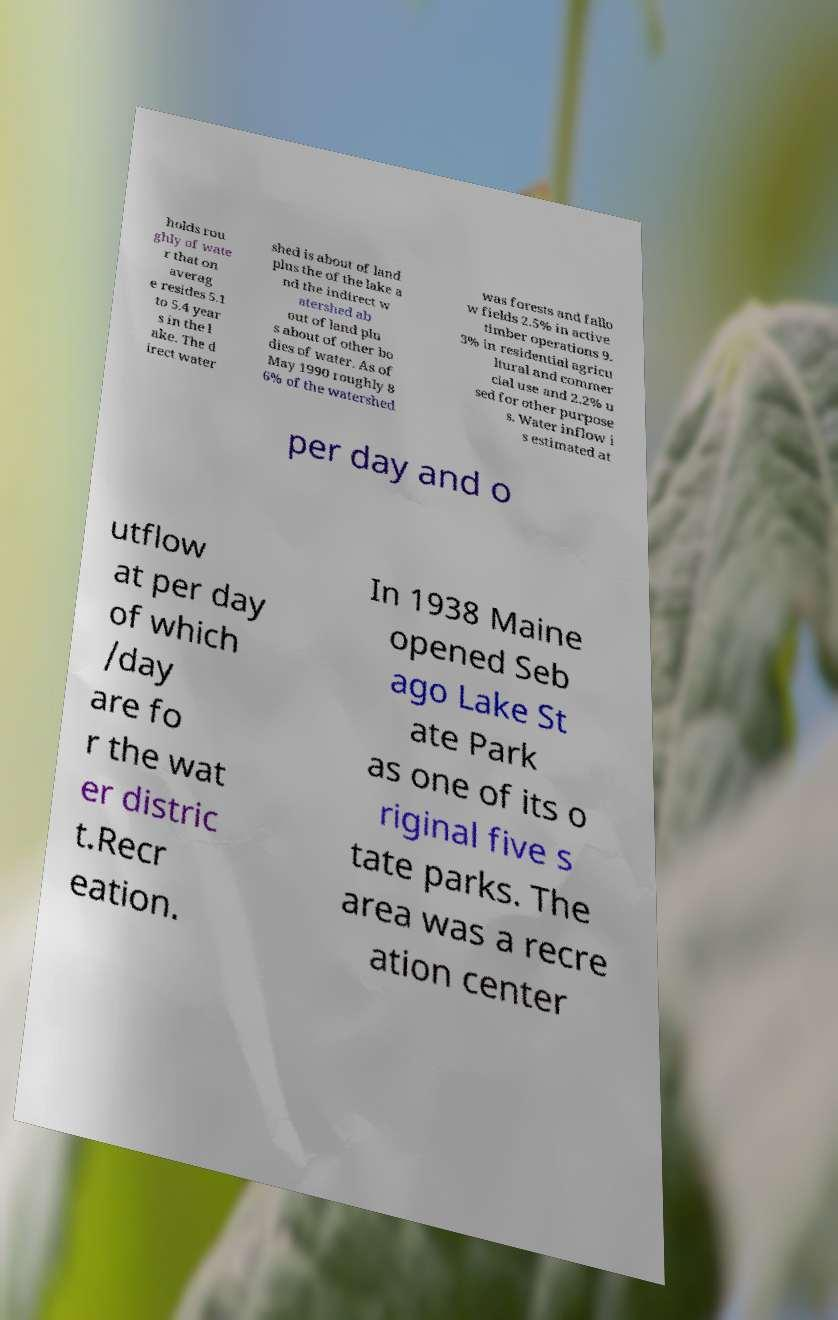For documentation purposes, I need the text within this image transcribed. Could you provide that? holds rou ghly of wate r that on averag e resides 5.1 to 5.4 year s in the l ake. The d irect water shed is about of land plus the of the lake a nd the indirect w atershed ab out of land plu s about of other bo dies of water. As of May 1990 roughly 8 6% of the watershed was forests and fallo w fields 2.5% in active timber operations 9. 3% in residential agricu ltural and commer cial use and 2.2% u sed for other purpose s. Water inflow i s estimated at per day and o utflow at per day of which /day are fo r the wat er distric t.Recr eation. In 1938 Maine opened Seb ago Lake St ate Park as one of its o riginal five s tate parks. The area was a recre ation center 